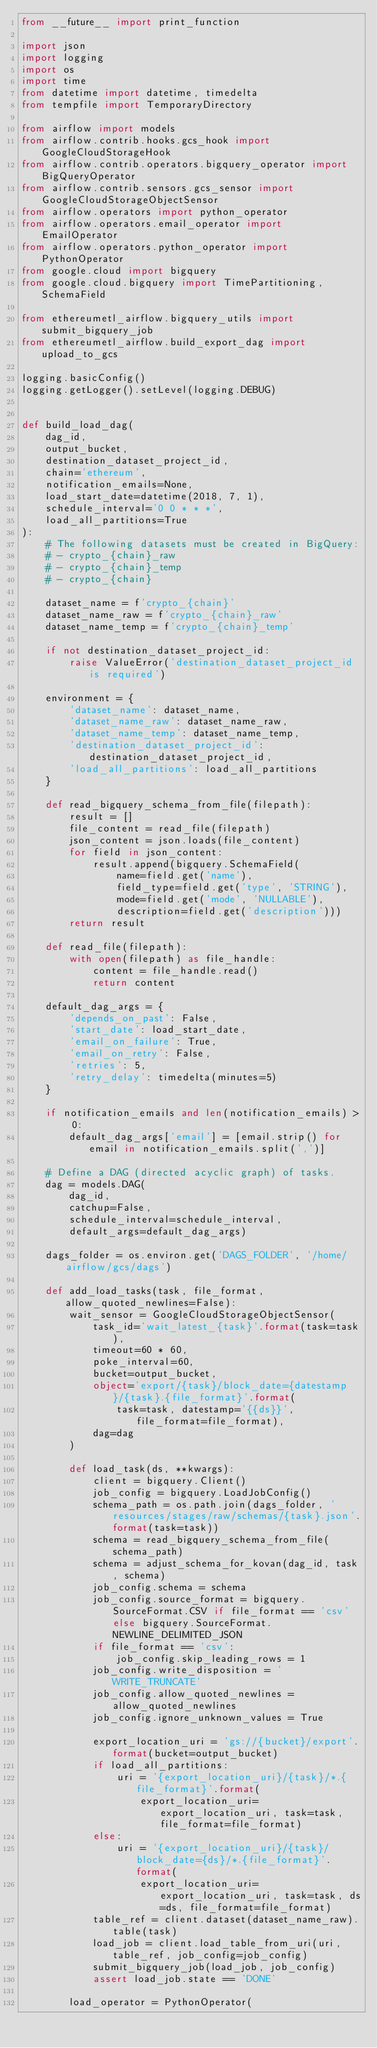Convert code to text. <code><loc_0><loc_0><loc_500><loc_500><_Python_>from __future__ import print_function

import json
import logging
import os
import time
from datetime import datetime, timedelta
from tempfile import TemporaryDirectory

from airflow import models
from airflow.contrib.hooks.gcs_hook import GoogleCloudStorageHook
from airflow.contrib.operators.bigquery_operator import BigQueryOperator
from airflow.contrib.sensors.gcs_sensor import GoogleCloudStorageObjectSensor
from airflow.operators import python_operator
from airflow.operators.email_operator import EmailOperator
from airflow.operators.python_operator import PythonOperator
from google.cloud import bigquery
from google.cloud.bigquery import TimePartitioning, SchemaField

from ethereumetl_airflow.bigquery_utils import submit_bigquery_job
from ethereumetl_airflow.build_export_dag import upload_to_gcs

logging.basicConfig()
logging.getLogger().setLevel(logging.DEBUG)


def build_load_dag(
    dag_id,
    output_bucket,
    destination_dataset_project_id,
    chain='ethereum',
    notification_emails=None,
    load_start_date=datetime(2018, 7, 1),
    schedule_interval='0 0 * * *',
    load_all_partitions=True
):
    # The following datasets must be created in BigQuery:
    # - crypto_{chain}_raw
    # - crypto_{chain}_temp
    # - crypto_{chain}

    dataset_name = f'crypto_{chain}'
    dataset_name_raw = f'crypto_{chain}_raw'
    dataset_name_temp = f'crypto_{chain}_temp'

    if not destination_dataset_project_id:
        raise ValueError('destination_dataset_project_id is required')

    environment = {
        'dataset_name': dataset_name,
        'dataset_name_raw': dataset_name_raw,
        'dataset_name_temp': dataset_name_temp,
        'destination_dataset_project_id': destination_dataset_project_id,
        'load_all_partitions': load_all_partitions
    }

    def read_bigquery_schema_from_file(filepath):
        result = []
        file_content = read_file(filepath)
        json_content = json.loads(file_content)
        for field in json_content:
            result.append(bigquery.SchemaField(
                name=field.get('name'),
                field_type=field.get('type', 'STRING'),
                mode=field.get('mode', 'NULLABLE'),
                description=field.get('description')))
        return result

    def read_file(filepath):
        with open(filepath) as file_handle:
            content = file_handle.read()
            return content

    default_dag_args = {
        'depends_on_past': False,
        'start_date': load_start_date,
        'email_on_failure': True,
        'email_on_retry': False,
        'retries': 5,
        'retry_delay': timedelta(minutes=5)
    }

    if notification_emails and len(notification_emails) > 0:
        default_dag_args['email'] = [email.strip() for email in notification_emails.split(',')]

    # Define a DAG (directed acyclic graph) of tasks.
    dag = models.DAG(
        dag_id,
        catchup=False,
        schedule_interval=schedule_interval,
        default_args=default_dag_args)

    dags_folder = os.environ.get('DAGS_FOLDER', '/home/airflow/gcs/dags')

    def add_load_tasks(task, file_format, allow_quoted_newlines=False):
        wait_sensor = GoogleCloudStorageObjectSensor(
            task_id='wait_latest_{task}'.format(task=task),
            timeout=60 * 60,
            poke_interval=60,
            bucket=output_bucket,
            object='export/{task}/block_date={datestamp}/{task}.{file_format}'.format(
                task=task, datestamp='{{ds}}', file_format=file_format),
            dag=dag
        )

        def load_task(ds, **kwargs):
            client = bigquery.Client()
            job_config = bigquery.LoadJobConfig()
            schema_path = os.path.join(dags_folder, 'resources/stages/raw/schemas/{task}.json'.format(task=task))
            schema = read_bigquery_schema_from_file(schema_path)
            schema = adjust_schema_for_kovan(dag_id, task, schema)
            job_config.schema = schema
            job_config.source_format = bigquery.SourceFormat.CSV if file_format == 'csv' else bigquery.SourceFormat.NEWLINE_DELIMITED_JSON
            if file_format == 'csv':
                job_config.skip_leading_rows = 1
            job_config.write_disposition = 'WRITE_TRUNCATE'
            job_config.allow_quoted_newlines = allow_quoted_newlines
            job_config.ignore_unknown_values = True

            export_location_uri = 'gs://{bucket}/export'.format(bucket=output_bucket)
            if load_all_partitions:
                uri = '{export_location_uri}/{task}/*.{file_format}'.format(
                    export_location_uri=export_location_uri, task=task, file_format=file_format)
            else:
                uri = '{export_location_uri}/{task}/block_date={ds}/*.{file_format}'.format(
                    export_location_uri=export_location_uri, task=task, ds=ds, file_format=file_format)
            table_ref = client.dataset(dataset_name_raw).table(task)
            load_job = client.load_table_from_uri(uri, table_ref, job_config=job_config)
            submit_bigquery_job(load_job, job_config)
            assert load_job.state == 'DONE'

        load_operator = PythonOperator(</code> 